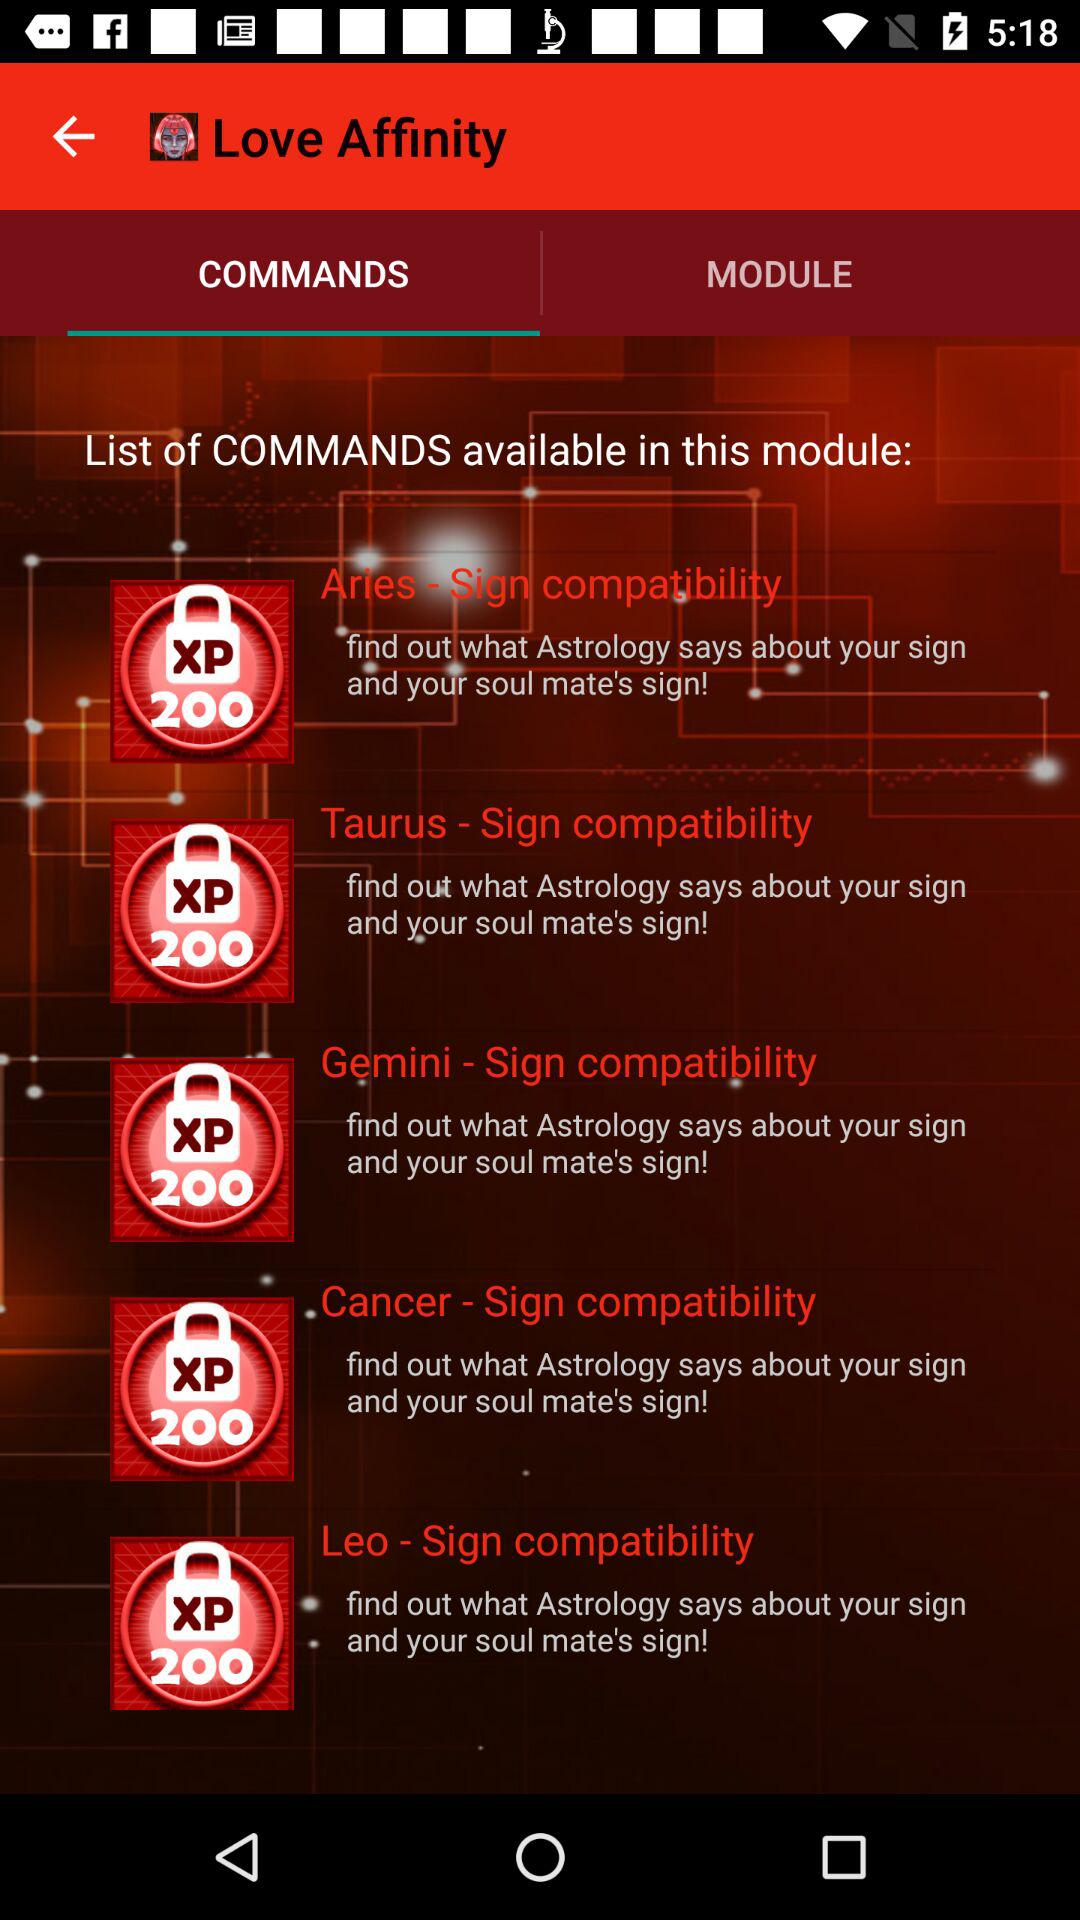Which tab is currently selected? The selected tab is "COMMANDS". 